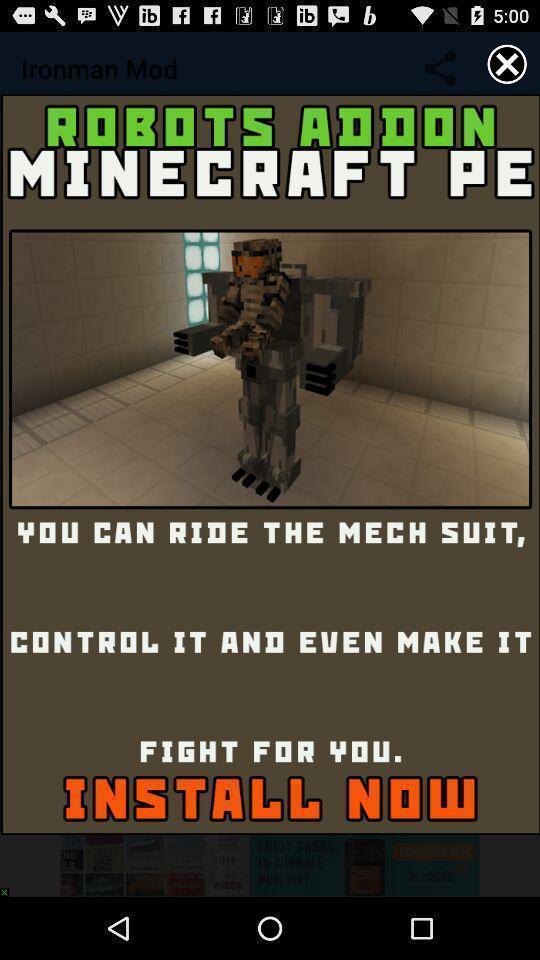Summarize the information in this screenshot. Pop-up showing an advertisement on an app to install. 